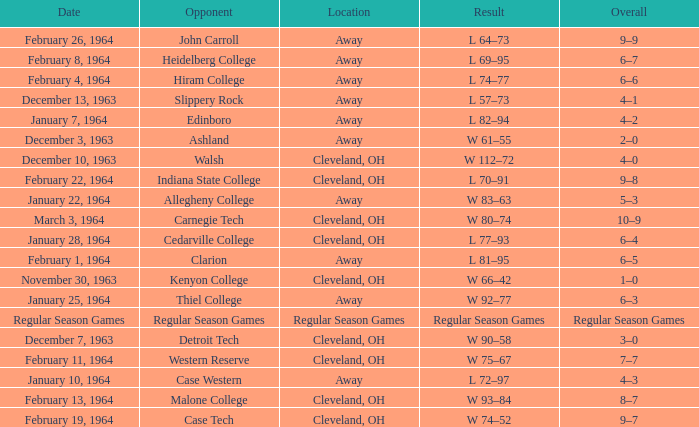What is the Date with an Opponent that is indiana state college? February 22, 1964. 